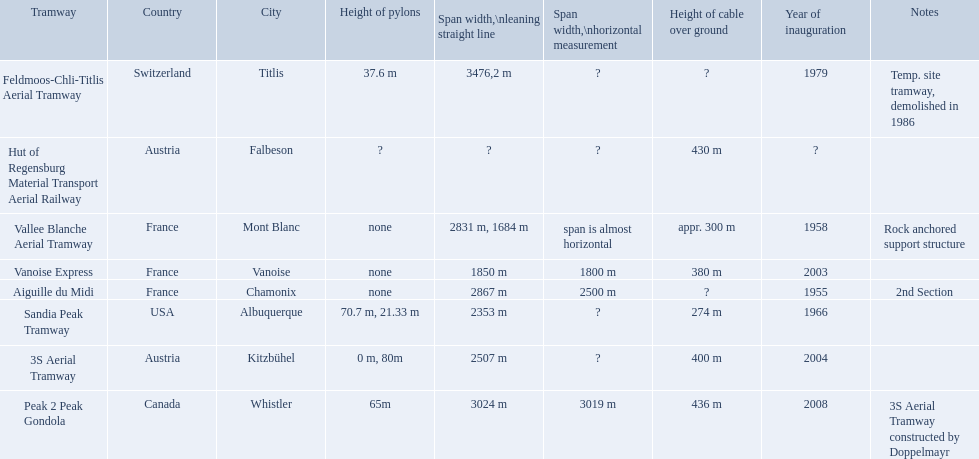What are all of the tramways? Peak 2 Peak Gondola, Hut of Regensburg Material Transport Aerial Railway, Vanoise Express, Aiguille du Midi, Vallee Blanche Aerial Tramway, 3S Aerial Tramway, Sandia Peak Tramway, Feldmoos-Chli-Titlis Aerial Tramway. When were they inaugurated? 2008, ?, 2003, 1955, 1958, 2004, 1966, 1979. Now, between 3s aerial tramway and aiguille du midi, which was inaugurated first? Aiguille du Midi. 